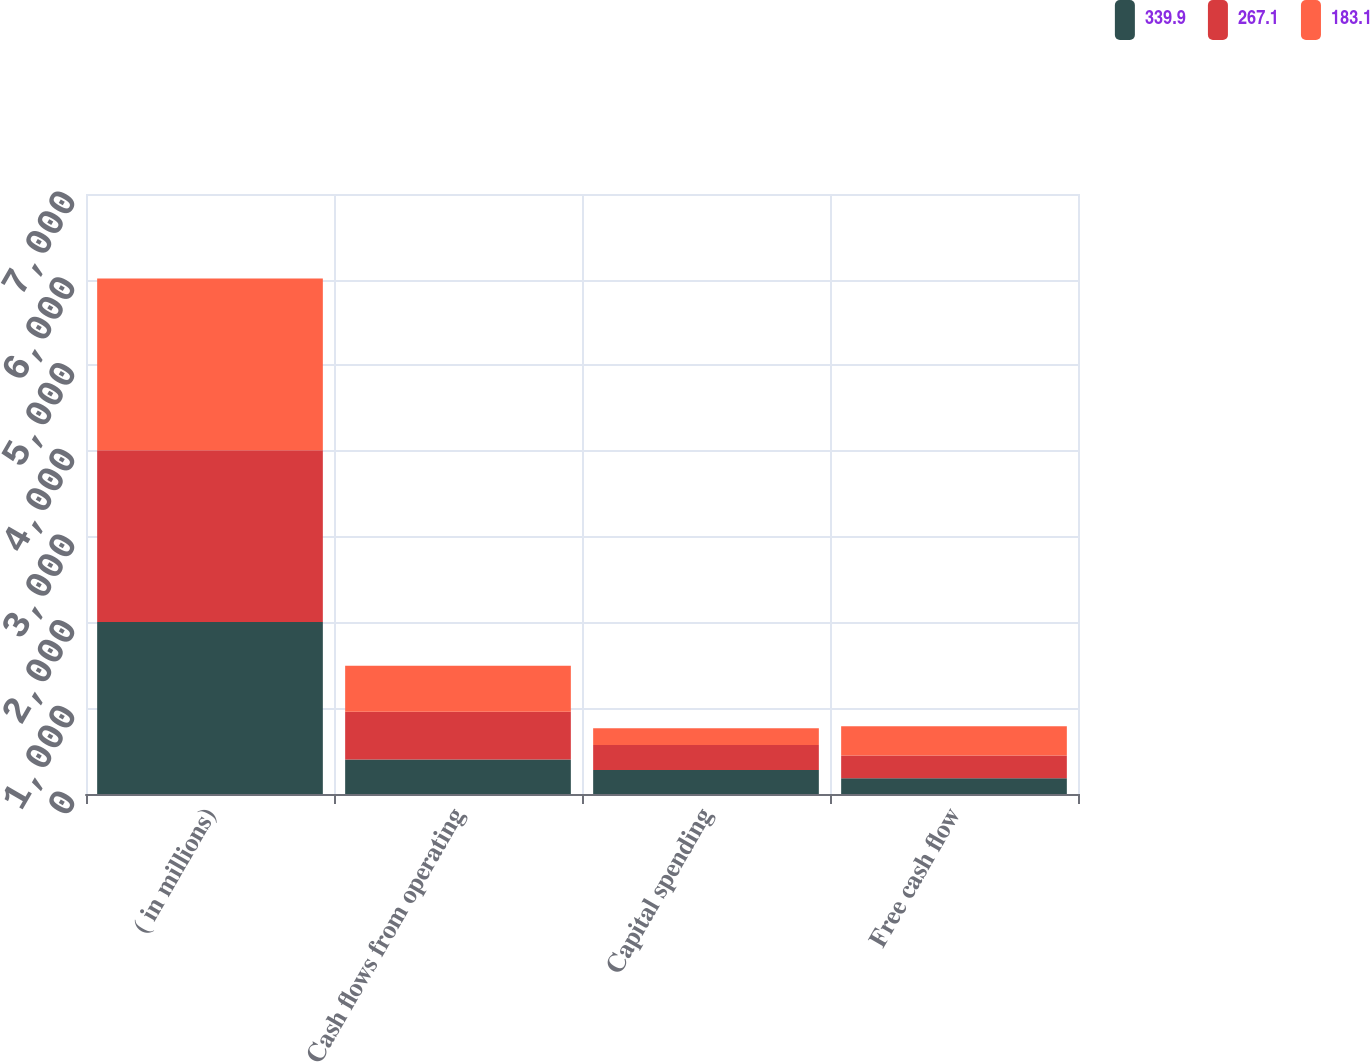<chart> <loc_0><loc_0><loc_500><loc_500><stacked_bar_chart><ecel><fcel>( in millions)<fcel>Cash flows from operating<fcel>Capital spending<fcel>Free cash flow<nl><fcel>339.9<fcel>2006<fcel>401.4<fcel>279.6<fcel>183.1<nl><fcel>267.1<fcel>2005<fcel>558.8<fcel>291.7<fcel>267.1<nl><fcel>183.1<fcel>2004<fcel>535.9<fcel>196<fcel>339.9<nl></chart> 